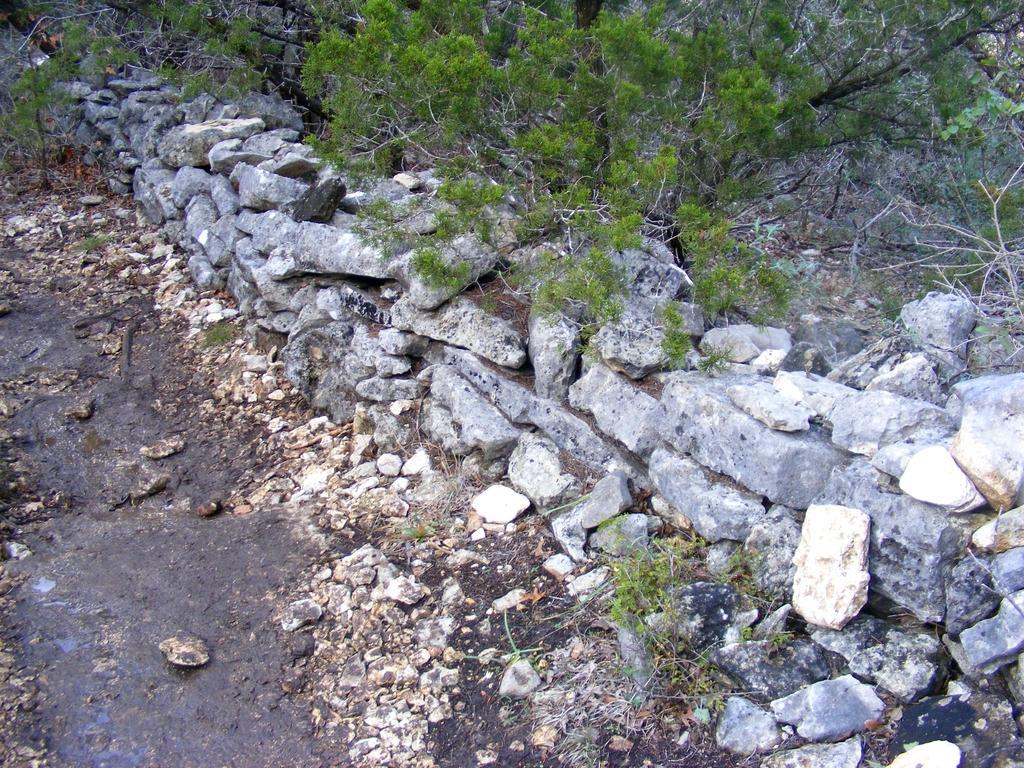Please provide a concise description of this image. In this image we can see stones and plants. 